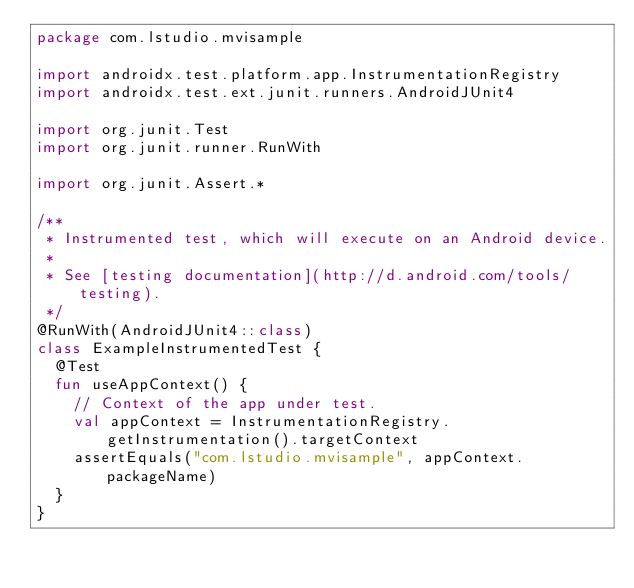<code> <loc_0><loc_0><loc_500><loc_500><_Kotlin_>package com.lstudio.mvisample

import androidx.test.platform.app.InstrumentationRegistry
import androidx.test.ext.junit.runners.AndroidJUnit4

import org.junit.Test
import org.junit.runner.RunWith

import org.junit.Assert.*

/**
 * Instrumented test, which will execute on an Android device.
 *
 * See [testing documentation](http://d.android.com/tools/testing).
 */
@RunWith(AndroidJUnit4::class)
class ExampleInstrumentedTest {
  @Test
  fun useAppContext() {
    // Context of the app under test.
    val appContext = InstrumentationRegistry.getInstrumentation().targetContext
    assertEquals("com.lstudio.mvisample", appContext.packageName)
  }
}</code> 